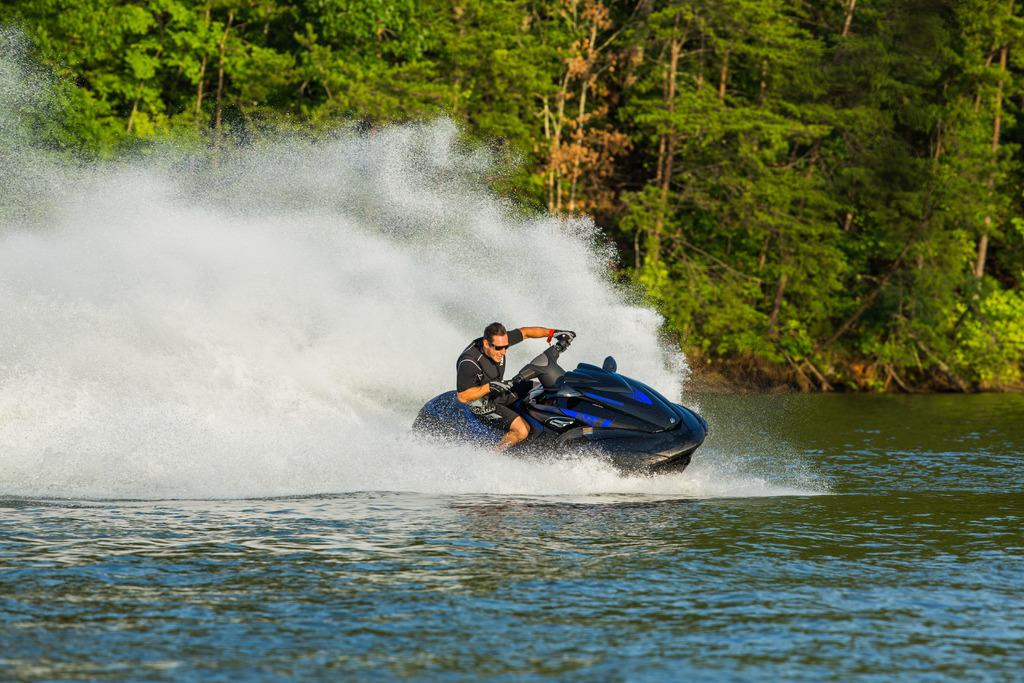What is the person in the image doing? There is a person riding a jet ski in the image. Where is the jet ski located? The jet ski is on water. What can be seen in the background of the image? There are trees visible in the background. What type of cheese is being used as a cushion on the jet ski? There is no cheese present in the image; the person is riding a jet ski on water. 